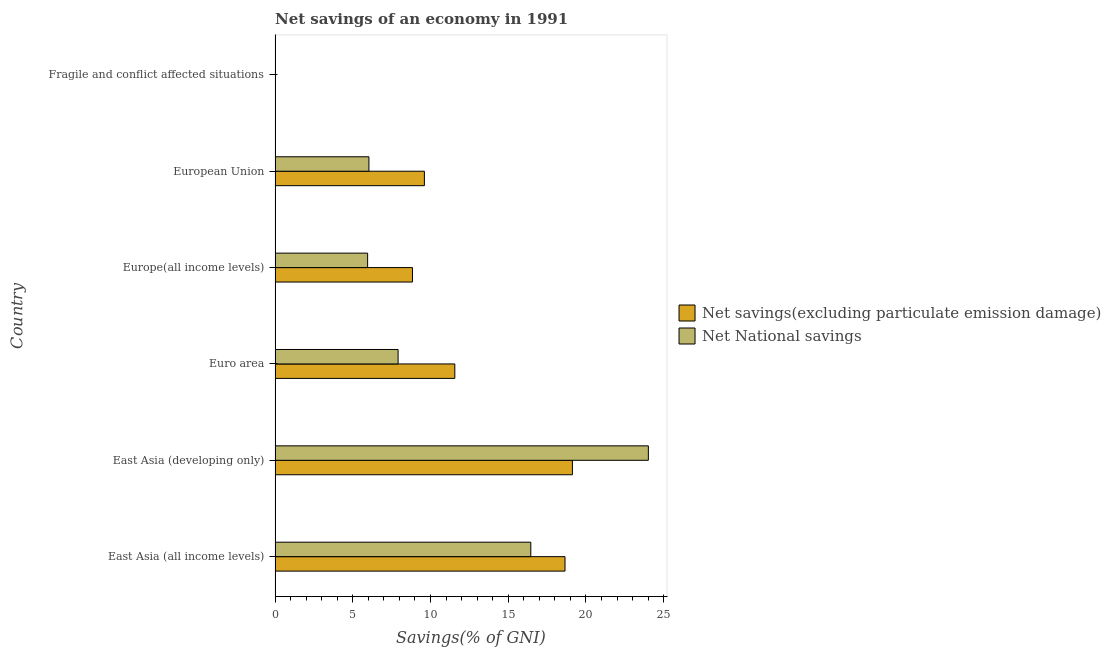Are the number of bars on each tick of the Y-axis equal?
Offer a very short reply. No. How many bars are there on the 3rd tick from the bottom?
Offer a terse response. 2. What is the net savings(excluding particulate emission damage) in Europe(all income levels)?
Provide a succinct answer. 8.84. Across all countries, what is the maximum net savings(excluding particulate emission damage)?
Your response must be concise. 19.13. In which country was the net national savings maximum?
Give a very brief answer. East Asia (developing only). What is the total net national savings in the graph?
Keep it short and to the point. 60.37. What is the difference between the net savings(excluding particulate emission damage) in East Asia (all income levels) and that in East Asia (developing only)?
Your response must be concise. -0.48. What is the difference between the net savings(excluding particulate emission damage) in Euro area and the net national savings in East Asia (developing only)?
Provide a succinct answer. -12.45. What is the average net national savings per country?
Your response must be concise. 10.06. What is the difference between the net national savings and net savings(excluding particulate emission damage) in Europe(all income levels)?
Make the answer very short. -2.88. In how many countries, is the net national savings greater than 15 %?
Your answer should be very brief. 2. What is the ratio of the net national savings in East Asia (developing only) to that in Europe(all income levels)?
Provide a succinct answer. 4.03. What is the difference between the highest and the second highest net national savings?
Make the answer very short. 7.56. What is the difference between the highest and the lowest net national savings?
Offer a very short reply. 24.02. Is the sum of the net savings(excluding particulate emission damage) in East Asia (developing only) and Europe(all income levels) greater than the maximum net national savings across all countries?
Make the answer very short. Yes. Are the values on the major ticks of X-axis written in scientific E-notation?
Offer a terse response. No. How many legend labels are there?
Keep it short and to the point. 2. How are the legend labels stacked?
Your answer should be very brief. Vertical. What is the title of the graph?
Your answer should be compact. Net savings of an economy in 1991. What is the label or title of the X-axis?
Your response must be concise. Savings(% of GNI). What is the Savings(% of GNI) in Net savings(excluding particulate emission damage) in East Asia (all income levels)?
Your answer should be very brief. 18.65. What is the Savings(% of GNI) of Net National savings in East Asia (all income levels)?
Provide a short and direct response. 16.45. What is the Savings(% of GNI) in Net savings(excluding particulate emission damage) in East Asia (developing only)?
Your answer should be very brief. 19.13. What is the Savings(% of GNI) of Net National savings in East Asia (developing only)?
Ensure brevity in your answer.  24.02. What is the Savings(% of GNI) in Net savings(excluding particulate emission damage) in Euro area?
Ensure brevity in your answer.  11.56. What is the Savings(% of GNI) of Net National savings in Euro area?
Your answer should be compact. 7.91. What is the Savings(% of GNI) in Net savings(excluding particulate emission damage) in Europe(all income levels)?
Offer a terse response. 8.84. What is the Savings(% of GNI) of Net National savings in Europe(all income levels)?
Make the answer very short. 5.95. What is the Savings(% of GNI) in Net savings(excluding particulate emission damage) in European Union?
Your response must be concise. 9.61. What is the Savings(% of GNI) of Net National savings in European Union?
Your answer should be compact. 6.04. What is the Savings(% of GNI) of Net National savings in Fragile and conflict affected situations?
Make the answer very short. 0. Across all countries, what is the maximum Savings(% of GNI) in Net savings(excluding particulate emission damage)?
Provide a succinct answer. 19.13. Across all countries, what is the maximum Savings(% of GNI) of Net National savings?
Make the answer very short. 24.02. Across all countries, what is the minimum Savings(% of GNI) in Net savings(excluding particulate emission damage)?
Make the answer very short. 0. What is the total Savings(% of GNI) in Net savings(excluding particulate emission damage) in the graph?
Your answer should be compact. 67.79. What is the total Savings(% of GNI) of Net National savings in the graph?
Your answer should be compact. 60.37. What is the difference between the Savings(% of GNI) in Net savings(excluding particulate emission damage) in East Asia (all income levels) and that in East Asia (developing only)?
Provide a succinct answer. -0.48. What is the difference between the Savings(% of GNI) of Net National savings in East Asia (all income levels) and that in East Asia (developing only)?
Ensure brevity in your answer.  -7.56. What is the difference between the Savings(% of GNI) of Net savings(excluding particulate emission damage) in East Asia (all income levels) and that in Euro area?
Offer a very short reply. 7.09. What is the difference between the Savings(% of GNI) in Net National savings in East Asia (all income levels) and that in Euro area?
Offer a terse response. 8.54. What is the difference between the Savings(% of GNI) of Net savings(excluding particulate emission damage) in East Asia (all income levels) and that in Europe(all income levels)?
Provide a short and direct response. 9.81. What is the difference between the Savings(% of GNI) of Net National savings in East Asia (all income levels) and that in Europe(all income levels)?
Your response must be concise. 10.5. What is the difference between the Savings(% of GNI) in Net savings(excluding particulate emission damage) in East Asia (all income levels) and that in European Union?
Your answer should be compact. 9.05. What is the difference between the Savings(% of GNI) in Net National savings in East Asia (all income levels) and that in European Union?
Give a very brief answer. 10.42. What is the difference between the Savings(% of GNI) in Net savings(excluding particulate emission damage) in East Asia (developing only) and that in Euro area?
Provide a short and direct response. 7.57. What is the difference between the Savings(% of GNI) in Net National savings in East Asia (developing only) and that in Euro area?
Your answer should be very brief. 16.1. What is the difference between the Savings(% of GNI) of Net savings(excluding particulate emission damage) in East Asia (developing only) and that in Europe(all income levels)?
Offer a terse response. 10.29. What is the difference between the Savings(% of GNI) in Net National savings in East Asia (developing only) and that in Europe(all income levels)?
Your answer should be compact. 18.06. What is the difference between the Savings(% of GNI) in Net savings(excluding particulate emission damage) in East Asia (developing only) and that in European Union?
Your answer should be compact. 9.52. What is the difference between the Savings(% of GNI) in Net National savings in East Asia (developing only) and that in European Union?
Provide a succinct answer. 17.98. What is the difference between the Savings(% of GNI) of Net savings(excluding particulate emission damage) in Euro area and that in Europe(all income levels)?
Keep it short and to the point. 2.72. What is the difference between the Savings(% of GNI) of Net National savings in Euro area and that in Europe(all income levels)?
Provide a succinct answer. 1.96. What is the difference between the Savings(% of GNI) of Net savings(excluding particulate emission damage) in Euro area and that in European Union?
Offer a terse response. 1.96. What is the difference between the Savings(% of GNI) of Net National savings in Euro area and that in European Union?
Your answer should be compact. 1.88. What is the difference between the Savings(% of GNI) in Net savings(excluding particulate emission damage) in Europe(all income levels) and that in European Union?
Give a very brief answer. -0.77. What is the difference between the Savings(% of GNI) in Net National savings in Europe(all income levels) and that in European Union?
Offer a very short reply. -0.08. What is the difference between the Savings(% of GNI) in Net savings(excluding particulate emission damage) in East Asia (all income levels) and the Savings(% of GNI) in Net National savings in East Asia (developing only)?
Provide a short and direct response. -5.36. What is the difference between the Savings(% of GNI) in Net savings(excluding particulate emission damage) in East Asia (all income levels) and the Savings(% of GNI) in Net National savings in Euro area?
Offer a very short reply. 10.74. What is the difference between the Savings(% of GNI) in Net savings(excluding particulate emission damage) in East Asia (all income levels) and the Savings(% of GNI) in Net National savings in Europe(all income levels)?
Your answer should be compact. 12.7. What is the difference between the Savings(% of GNI) of Net savings(excluding particulate emission damage) in East Asia (all income levels) and the Savings(% of GNI) of Net National savings in European Union?
Keep it short and to the point. 12.62. What is the difference between the Savings(% of GNI) in Net savings(excluding particulate emission damage) in East Asia (developing only) and the Savings(% of GNI) in Net National savings in Euro area?
Give a very brief answer. 11.21. What is the difference between the Savings(% of GNI) in Net savings(excluding particulate emission damage) in East Asia (developing only) and the Savings(% of GNI) in Net National savings in Europe(all income levels)?
Keep it short and to the point. 13.17. What is the difference between the Savings(% of GNI) of Net savings(excluding particulate emission damage) in East Asia (developing only) and the Savings(% of GNI) of Net National savings in European Union?
Give a very brief answer. 13.09. What is the difference between the Savings(% of GNI) of Net savings(excluding particulate emission damage) in Euro area and the Savings(% of GNI) of Net National savings in Europe(all income levels)?
Provide a succinct answer. 5.61. What is the difference between the Savings(% of GNI) of Net savings(excluding particulate emission damage) in Euro area and the Savings(% of GNI) of Net National savings in European Union?
Your answer should be very brief. 5.53. What is the difference between the Savings(% of GNI) of Net savings(excluding particulate emission damage) in Europe(all income levels) and the Savings(% of GNI) of Net National savings in European Union?
Provide a short and direct response. 2.8. What is the average Savings(% of GNI) in Net savings(excluding particulate emission damage) per country?
Your answer should be compact. 11.3. What is the average Savings(% of GNI) of Net National savings per country?
Your answer should be very brief. 10.06. What is the difference between the Savings(% of GNI) of Net savings(excluding particulate emission damage) and Savings(% of GNI) of Net National savings in East Asia (all income levels)?
Your answer should be very brief. 2.2. What is the difference between the Savings(% of GNI) in Net savings(excluding particulate emission damage) and Savings(% of GNI) in Net National savings in East Asia (developing only)?
Ensure brevity in your answer.  -4.89. What is the difference between the Savings(% of GNI) of Net savings(excluding particulate emission damage) and Savings(% of GNI) of Net National savings in Euro area?
Your response must be concise. 3.65. What is the difference between the Savings(% of GNI) of Net savings(excluding particulate emission damage) and Savings(% of GNI) of Net National savings in Europe(all income levels)?
Offer a very short reply. 2.89. What is the difference between the Savings(% of GNI) of Net savings(excluding particulate emission damage) and Savings(% of GNI) of Net National savings in European Union?
Your response must be concise. 3.57. What is the ratio of the Savings(% of GNI) in Net savings(excluding particulate emission damage) in East Asia (all income levels) to that in East Asia (developing only)?
Offer a very short reply. 0.98. What is the ratio of the Savings(% of GNI) in Net National savings in East Asia (all income levels) to that in East Asia (developing only)?
Your answer should be compact. 0.69. What is the ratio of the Savings(% of GNI) of Net savings(excluding particulate emission damage) in East Asia (all income levels) to that in Euro area?
Your answer should be compact. 1.61. What is the ratio of the Savings(% of GNI) of Net National savings in East Asia (all income levels) to that in Euro area?
Your answer should be compact. 2.08. What is the ratio of the Savings(% of GNI) in Net savings(excluding particulate emission damage) in East Asia (all income levels) to that in Europe(all income levels)?
Your answer should be very brief. 2.11. What is the ratio of the Savings(% of GNI) of Net National savings in East Asia (all income levels) to that in Europe(all income levels)?
Give a very brief answer. 2.76. What is the ratio of the Savings(% of GNI) in Net savings(excluding particulate emission damage) in East Asia (all income levels) to that in European Union?
Ensure brevity in your answer.  1.94. What is the ratio of the Savings(% of GNI) in Net National savings in East Asia (all income levels) to that in European Union?
Keep it short and to the point. 2.73. What is the ratio of the Savings(% of GNI) in Net savings(excluding particulate emission damage) in East Asia (developing only) to that in Euro area?
Provide a succinct answer. 1.65. What is the ratio of the Savings(% of GNI) in Net National savings in East Asia (developing only) to that in Euro area?
Provide a succinct answer. 3.03. What is the ratio of the Savings(% of GNI) in Net savings(excluding particulate emission damage) in East Asia (developing only) to that in Europe(all income levels)?
Your answer should be very brief. 2.16. What is the ratio of the Savings(% of GNI) in Net National savings in East Asia (developing only) to that in Europe(all income levels)?
Your answer should be very brief. 4.03. What is the ratio of the Savings(% of GNI) of Net savings(excluding particulate emission damage) in East Asia (developing only) to that in European Union?
Your response must be concise. 1.99. What is the ratio of the Savings(% of GNI) of Net National savings in East Asia (developing only) to that in European Union?
Give a very brief answer. 3.98. What is the ratio of the Savings(% of GNI) in Net savings(excluding particulate emission damage) in Euro area to that in Europe(all income levels)?
Offer a very short reply. 1.31. What is the ratio of the Savings(% of GNI) in Net National savings in Euro area to that in Europe(all income levels)?
Your response must be concise. 1.33. What is the ratio of the Savings(% of GNI) of Net savings(excluding particulate emission damage) in Euro area to that in European Union?
Keep it short and to the point. 1.2. What is the ratio of the Savings(% of GNI) of Net National savings in Euro area to that in European Union?
Your response must be concise. 1.31. What is the ratio of the Savings(% of GNI) of Net savings(excluding particulate emission damage) in Europe(all income levels) to that in European Union?
Keep it short and to the point. 0.92. What is the ratio of the Savings(% of GNI) in Net National savings in Europe(all income levels) to that in European Union?
Provide a short and direct response. 0.99. What is the difference between the highest and the second highest Savings(% of GNI) in Net savings(excluding particulate emission damage)?
Ensure brevity in your answer.  0.48. What is the difference between the highest and the second highest Savings(% of GNI) of Net National savings?
Give a very brief answer. 7.56. What is the difference between the highest and the lowest Savings(% of GNI) in Net savings(excluding particulate emission damage)?
Keep it short and to the point. 19.13. What is the difference between the highest and the lowest Savings(% of GNI) in Net National savings?
Provide a succinct answer. 24.02. 